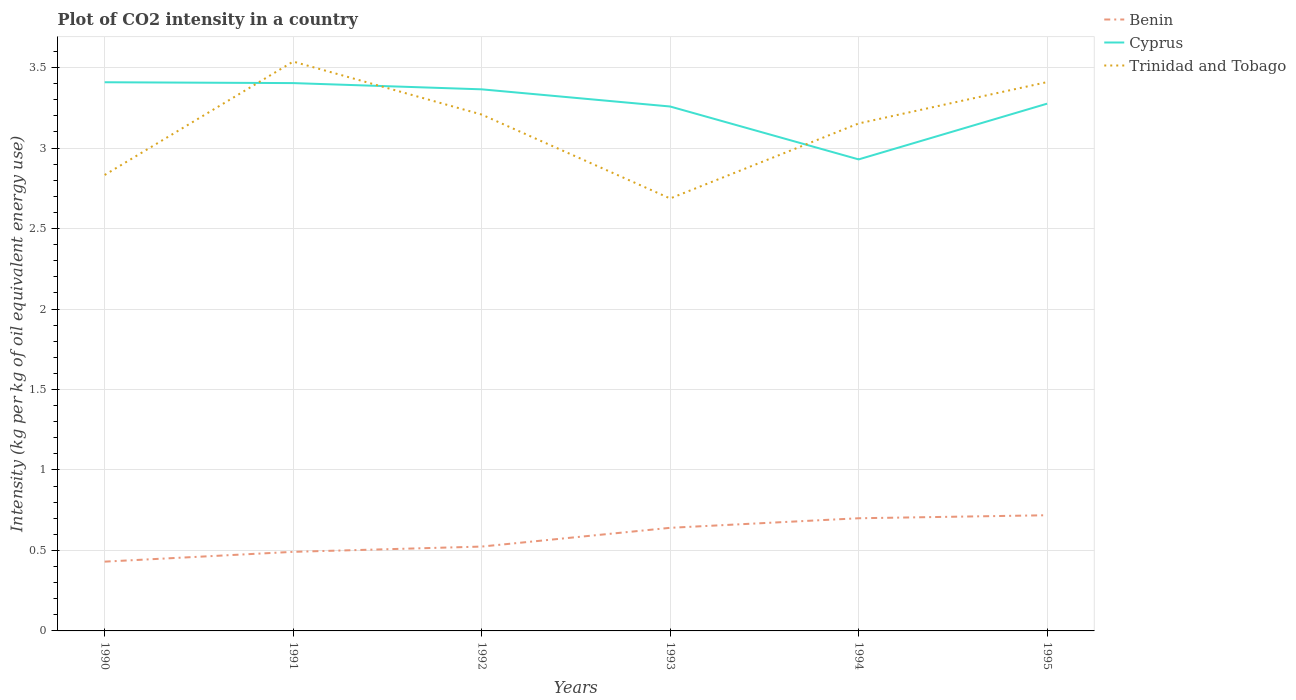How many different coloured lines are there?
Provide a succinct answer. 3. Does the line corresponding to Trinidad and Tobago intersect with the line corresponding to Cyprus?
Provide a succinct answer. Yes. Across all years, what is the maximum CO2 intensity in in Cyprus?
Your answer should be very brief. 2.93. What is the total CO2 intensity in in Benin in the graph?
Make the answer very short. -0.29. What is the difference between the highest and the second highest CO2 intensity in in Trinidad and Tobago?
Your response must be concise. 0.85. How many years are there in the graph?
Your answer should be compact. 6. Are the values on the major ticks of Y-axis written in scientific E-notation?
Offer a very short reply. No. Does the graph contain any zero values?
Your answer should be very brief. No. Where does the legend appear in the graph?
Your response must be concise. Top right. How many legend labels are there?
Make the answer very short. 3. What is the title of the graph?
Make the answer very short. Plot of CO2 intensity in a country. What is the label or title of the Y-axis?
Keep it short and to the point. Intensity (kg per kg of oil equivalent energy use). What is the Intensity (kg per kg of oil equivalent energy use) in Benin in 1990?
Provide a short and direct response. 0.43. What is the Intensity (kg per kg of oil equivalent energy use) in Cyprus in 1990?
Your response must be concise. 3.41. What is the Intensity (kg per kg of oil equivalent energy use) in Trinidad and Tobago in 1990?
Provide a short and direct response. 2.83. What is the Intensity (kg per kg of oil equivalent energy use) of Benin in 1991?
Make the answer very short. 0.49. What is the Intensity (kg per kg of oil equivalent energy use) in Cyprus in 1991?
Your answer should be very brief. 3.4. What is the Intensity (kg per kg of oil equivalent energy use) in Trinidad and Tobago in 1991?
Offer a very short reply. 3.54. What is the Intensity (kg per kg of oil equivalent energy use) of Benin in 1992?
Your answer should be very brief. 0.52. What is the Intensity (kg per kg of oil equivalent energy use) of Cyprus in 1992?
Make the answer very short. 3.36. What is the Intensity (kg per kg of oil equivalent energy use) in Trinidad and Tobago in 1992?
Keep it short and to the point. 3.21. What is the Intensity (kg per kg of oil equivalent energy use) in Benin in 1993?
Provide a short and direct response. 0.64. What is the Intensity (kg per kg of oil equivalent energy use) in Cyprus in 1993?
Your answer should be compact. 3.26. What is the Intensity (kg per kg of oil equivalent energy use) of Trinidad and Tobago in 1993?
Your answer should be very brief. 2.69. What is the Intensity (kg per kg of oil equivalent energy use) in Benin in 1994?
Provide a succinct answer. 0.7. What is the Intensity (kg per kg of oil equivalent energy use) of Cyprus in 1994?
Keep it short and to the point. 2.93. What is the Intensity (kg per kg of oil equivalent energy use) of Trinidad and Tobago in 1994?
Offer a very short reply. 3.15. What is the Intensity (kg per kg of oil equivalent energy use) of Benin in 1995?
Provide a succinct answer. 0.72. What is the Intensity (kg per kg of oil equivalent energy use) of Cyprus in 1995?
Make the answer very short. 3.28. What is the Intensity (kg per kg of oil equivalent energy use) in Trinidad and Tobago in 1995?
Offer a very short reply. 3.41. Across all years, what is the maximum Intensity (kg per kg of oil equivalent energy use) in Benin?
Provide a succinct answer. 0.72. Across all years, what is the maximum Intensity (kg per kg of oil equivalent energy use) in Cyprus?
Keep it short and to the point. 3.41. Across all years, what is the maximum Intensity (kg per kg of oil equivalent energy use) of Trinidad and Tobago?
Give a very brief answer. 3.54. Across all years, what is the minimum Intensity (kg per kg of oil equivalent energy use) in Benin?
Your answer should be compact. 0.43. Across all years, what is the minimum Intensity (kg per kg of oil equivalent energy use) in Cyprus?
Make the answer very short. 2.93. Across all years, what is the minimum Intensity (kg per kg of oil equivalent energy use) in Trinidad and Tobago?
Offer a very short reply. 2.69. What is the total Intensity (kg per kg of oil equivalent energy use) of Benin in the graph?
Your answer should be compact. 3.51. What is the total Intensity (kg per kg of oil equivalent energy use) in Cyprus in the graph?
Ensure brevity in your answer.  19.64. What is the total Intensity (kg per kg of oil equivalent energy use) of Trinidad and Tobago in the graph?
Give a very brief answer. 18.83. What is the difference between the Intensity (kg per kg of oil equivalent energy use) in Benin in 1990 and that in 1991?
Your response must be concise. -0.06. What is the difference between the Intensity (kg per kg of oil equivalent energy use) in Cyprus in 1990 and that in 1991?
Keep it short and to the point. 0.01. What is the difference between the Intensity (kg per kg of oil equivalent energy use) in Trinidad and Tobago in 1990 and that in 1991?
Make the answer very short. -0.7. What is the difference between the Intensity (kg per kg of oil equivalent energy use) of Benin in 1990 and that in 1992?
Your answer should be very brief. -0.09. What is the difference between the Intensity (kg per kg of oil equivalent energy use) in Cyprus in 1990 and that in 1992?
Provide a succinct answer. 0.04. What is the difference between the Intensity (kg per kg of oil equivalent energy use) in Trinidad and Tobago in 1990 and that in 1992?
Ensure brevity in your answer.  -0.38. What is the difference between the Intensity (kg per kg of oil equivalent energy use) in Benin in 1990 and that in 1993?
Your answer should be compact. -0.21. What is the difference between the Intensity (kg per kg of oil equivalent energy use) of Cyprus in 1990 and that in 1993?
Ensure brevity in your answer.  0.15. What is the difference between the Intensity (kg per kg of oil equivalent energy use) in Trinidad and Tobago in 1990 and that in 1993?
Keep it short and to the point. 0.15. What is the difference between the Intensity (kg per kg of oil equivalent energy use) in Benin in 1990 and that in 1994?
Keep it short and to the point. -0.27. What is the difference between the Intensity (kg per kg of oil equivalent energy use) of Cyprus in 1990 and that in 1994?
Keep it short and to the point. 0.48. What is the difference between the Intensity (kg per kg of oil equivalent energy use) of Trinidad and Tobago in 1990 and that in 1994?
Your answer should be compact. -0.32. What is the difference between the Intensity (kg per kg of oil equivalent energy use) of Benin in 1990 and that in 1995?
Give a very brief answer. -0.29. What is the difference between the Intensity (kg per kg of oil equivalent energy use) in Cyprus in 1990 and that in 1995?
Keep it short and to the point. 0.13. What is the difference between the Intensity (kg per kg of oil equivalent energy use) of Trinidad and Tobago in 1990 and that in 1995?
Provide a succinct answer. -0.58. What is the difference between the Intensity (kg per kg of oil equivalent energy use) of Benin in 1991 and that in 1992?
Your response must be concise. -0.03. What is the difference between the Intensity (kg per kg of oil equivalent energy use) of Cyprus in 1991 and that in 1992?
Offer a very short reply. 0.04. What is the difference between the Intensity (kg per kg of oil equivalent energy use) of Trinidad and Tobago in 1991 and that in 1992?
Offer a terse response. 0.33. What is the difference between the Intensity (kg per kg of oil equivalent energy use) in Benin in 1991 and that in 1993?
Your answer should be compact. -0.15. What is the difference between the Intensity (kg per kg of oil equivalent energy use) of Cyprus in 1991 and that in 1993?
Give a very brief answer. 0.15. What is the difference between the Intensity (kg per kg of oil equivalent energy use) of Trinidad and Tobago in 1991 and that in 1993?
Provide a succinct answer. 0.85. What is the difference between the Intensity (kg per kg of oil equivalent energy use) of Benin in 1991 and that in 1994?
Your answer should be very brief. -0.21. What is the difference between the Intensity (kg per kg of oil equivalent energy use) in Cyprus in 1991 and that in 1994?
Keep it short and to the point. 0.47. What is the difference between the Intensity (kg per kg of oil equivalent energy use) in Trinidad and Tobago in 1991 and that in 1994?
Provide a succinct answer. 0.38. What is the difference between the Intensity (kg per kg of oil equivalent energy use) in Benin in 1991 and that in 1995?
Provide a succinct answer. -0.23. What is the difference between the Intensity (kg per kg of oil equivalent energy use) of Cyprus in 1991 and that in 1995?
Offer a very short reply. 0.13. What is the difference between the Intensity (kg per kg of oil equivalent energy use) of Trinidad and Tobago in 1991 and that in 1995?
Ensure brevity in your answer.  0.13. What is the difference between the Intensity (kg per kg of oil equivalent energy use) of Benin in 1992 and that in 1993?
Offer a very short reply. -0.12. What is the difference between the Intensity (kg per kg of oil equivalent energy use) of Cyprus in 1992 and that in 1993?
Provide a short and direct response. 0.11. What is the difference between the Intensity (kg per kg of oil equivalent energy use) in Trinidad and Tobago in 1992 and that in 1993?
Make the answer very short. 0.52. What is the difference between the Intensity (kg per kg of oil equivalent energy use) in Benin in 1992 and that in 1994?
Make the answer very short. -0.18. What is the difference between the Intensity (kg per kg of oil equivalent energy use) of Cyprus in 1992 and that in 1994?
Give a very brief answer. 0.44. What is the difference between the Intensity (kg per kg of oil equivalent energy use) in Trinidad and Tobago in 1992 and that in 1994?
Provide a succinct answer. 0.06. What is the difference between the Intensity (kg per kg of oil equivalent energy use) in Benin in 1992 and that in 1995?
Your response must be concise. -0.19. What is the difference between the Intensity (kg per kg of oil equivalent energy use) in Cyprus in 1992 and that in 1995?
Make the answer very short. 0.09. What is the difference between the Intensity (kg per kg of oil equivalent energy use) of Trinidad and Tobago in 1992 and that in 1995?
Your answer should be very brief. -0.2. What is the difference between the Intensity (kg per kg of oil equivalent energy use) of Benin in 1993 and that in 1994?
Your answer should be very brief. -0.06. What is the difference between the Intensity (kg per kg of oil equivalent energy use) in Cyprus in 1993 and that in 1994?
Provide a succinct answer. 0.33. What is the difference between the Intensity (kg per kg of oil equivalent energy use) of Trinidad and Tobago in 1993 and that in 1994?
Give a very brief answer. -0.47. What is the difference between the Intensity (kg per kg of oil equivalent energy use) of Benin in 1993 and that in 1995?
Your answer should be very brief. -0.08. What is the difference between the Intensity (kg per kg of oil equivalent energy use) of Cyprus in 1993 and that in 1995?
Offer a very short reply. -0.02. What is the difference between the Intensity (kg per kg of oil equivalent energy use) of Trinidad and Tobago in 1993 and that in 1995?
Your answer should be very brief. -0.72. What is the difference between the Intensity (kg per kg of oil equivalent energy use) of Benin in 1994 and that in 1995?
Provide a succinct answer. -0.02. What is the difference between the Intensity (kg per kg of oil equivalent energy use) in Cyprus in 1994 and that in 1995?
Your answer should be very brief. -0.35. What is the difference between the Intensity (kg per kg of oil equivalent energy use) of Trinidad and Tobago in 1994 and that in 1995?
Provide a short and direct response. -0.26. What is the difference between the Intensity (kg per kg of oil equivalent energy use) of Benin in 1990 and the Intensity (kg per kg of oil equivalent energy use) of Cyprus in 1991?
Offer a very short reply. -2.97. What is the difference between the Intensity (kg per kg of oil equivalent energy use) in Benin in 1990 and the Intensity (kg per kg of oil equivalent energy use) in Trinidad and Tobago in 1991?
Your response must be concise. -3.11. What is the difference between the Intensity (kg per kg of oil equivalent energy use) of Cyprus in 1990 and the Intensity (kg per kg of oil equivalent energy use) of Trinidad and Tobago in 1991?
Provide a succinct answer. -0.13. What is the difference between the Intensity (kg per kg of oil equivalent energy use) in Benin in 1990 and the Intensity (kg per kg of oil equivalent energy use) in Cyprus in 1992?
Offer a terse response. -2.93. What is the difference between the Intensity (kg per kg of oil equivalent energy use) in Benin in 1990 and the Intensity (kg per kg of oil equivalent energy use) in Trinidad and Tobago in 1992?
Your answer should be compact. -2.78. What is the difference between the Intensity (kg per kg of oil equivalent energy use) of Cyprus in 1990 and the Intensity (kg per kg of oil equivalent energy use) of Trinidad and Tobago in 1992?
Your answer should be very brief. 0.2. What is the difference between the Intensity (kg per kg of oil equivalent energy use) of Benin in 1990 and the Intensity (kg per kg of oil equivalent energy use) of Cyprus in 1993?
Your answer should be very brief. -2.83. What is the difference between the Intensity (kg per kg of oil equivalent energy use) in Benin in 1990 and the Intensity (kg per kg of oil equivalent energy use) in Trinidad and Tobago in 1993?
Provide a short and direct response. -2.26. What is the difference between the Intensity (kg per kg of oil equivalent energy use) in Cyprus in 1990 and the Intensity (kg per kg of oil equivalent energy use) in Trinidad and Tobago in 1993?
Keep it short and to the point. 0.72. What is the difference between the Intensity (kg per kg of oil equivalent energy use) of Benin in 1990 and the Intensity (kg per kg of oil equivalent energy use) of Cyprus in 1994?
Offer a terse response. -2.5. What is the difference between the Intensity (kg per kg of oil equivalent energy use) of Benin in 1990 and the Intensity (kg per kg of oil equivalent energy use) of Trinidad and Tobago in 1994?
Make the answer very short. -2.72. What is the difference between the Intensity (kg per kg of oil equivalent energy use) in Cyprus in 1990 and the Intensity (kg per kg of oil equivalent energy use) in Trinidad and Tobago in 1994?
Ensure brevity in your answer.  0.26. What is the difference between the Intensity (kg per kg of oil equivalent energy use) of Benin in 1990 and the Intensity (kg per kg of oil equivalent energy use) of Cyprus in 1995?
Provide a succinct answer. -2.85. What is the difference between the Intensity (kg per kg of oil equivalent energy use) of Benin in 1990 and the Intensity (kg per kg of oil equivalent energy use) of Trinidad and Tobago in 1995?
Your response must be concise. -2.98. What is the difference between the Intensity (kg per kg of oil equivalent energy use) in Cyprus in 1990 and the Intensity (kg per kg of oil equivalent energy use) in Trinidad and Tobago in 1995?
Provide a succinct answer. -0. What is the difference between the Intensity (kg per kg of oil equivalent energy use) in Benin in 1991 and the Intensity (kg per kg of oil equivalent energy use) in Cyprus in 1992?
Offer a terse response. -2.87. What is the difference between the Intensity (kg per kg of oil equivalent energy use) of Benin in 1991 and the Intensity (kg per kg of oil equivalent energy use) of Trinidad and Tobago in 1992?
Your answer should be very brief. -2.72. What is the difference between the Intensity (kg per kg of oil equivalent energy use) of Cyprus in 1991 and the Intensity (kg per kg of oil equivalent energy use) of Trinidad and Tobago in 1992?
Make the answer very short. 0.2. What is the difference between the Intensity (kg per kg of oil equivalent energy use) in Benin in 1991 and the Intensity (kg per kg of oil equivalent energy use) in Cyprus in 1993?
Your answer should be very brief. -2.77. What is the difference between the Intensity (kg per kg of oil equivalent energy use) of Benin in 1991 and the Intensity (kg per kg of oil equivalent energy use) of Trinidad and Tobago in 1993?
Offer a very short reply. -2.2. What is the difference between the Intensity (kg per kg of oil equivalent energy use) of Cyprus in 1991 and the Intensity (kg per kg of oil equivalent energy use) of Trinidad and Tobago in 1993?
Your answer should be compact. 0.72. What is the difference between the Intensity (kg per kg of oil equivalent energy use) of Benin in 1991 and the Intensity (kg per kg of oil equivalent energy use) of Cyprus in 1994?
Offer a terse response. -2.44. What is the difference between the Intensity (kg per kg of oil equivalent energy use) of Benin in 1991 and the Intensity (kg per kg of oil equivalent energy use) of Trinidad and Tobago in 1994?
Ensure brevity in your answer.  -2.66. What is the difference between the Intensity (kg per kg of oil equivalent energy use) of Cyprus in 1991 and the Intensity (kg per kg of oil equivalent energy use) of Trinidad and Tobago in 1994?
Offer a terse response. 0.25. What is the difference between the Intensity (kg per kg of oil equivalent energy use) of Benin in 1991 and the Intensity (kg per kg of oil equivalent energy use) of Cyprus in 1995?
Provide a succinct answer. -2.78. What is the difference between the Intensity (kg per kg of oil equivalent energy use) of Benin in 1991 and the Intensity (kg per kg of oil equivalent energy use) of Trinidad and Tobago in 1995?
Provide a succinct answer. -2.92. What is the difference between the Intensity (kg per kg of oil equivalent energy use) of Cyprus in 1991 and the Intensity (kg per kg of oil equivalent energy use) of Trinidad and Tobago in 1995?
Your answer should be compact. -0.01. What is the difference between the Intensity (kg per kg of oil equivalent energy use) of Benin in 1992 and the Intensity (kg per kg of oil equivalent energy use) of Cyprus in 1993?
Give a very brief answer. -2.73. What is the difference between the Intensity (kg per kg of oil equivalent energy use) in Benin in 1992 and the Intensity (kg per kg of oil equivalent energy use) in Trinidad and Tobago in 1993?
Keep it short and to the point. -2.16. What is the difference between the Intensity (kg per kg of oil equivalent energy use) of Cyprus in 1992 and the Intensity (kg per kg of oil equivalent energy use) of Trinidad and Tobago in 1993?
Offer a very short reply. 0.68. What is the difference between the Intensity (kg per kg of oil equivalent energy use) of Benin in 1992 and the Intensity (kg per kg of oil equivalent energy use) of Cyprus in 1994?
Provide a short and direct response. -2.41. What is the difference between the Intensity (kg per kg of oil equivalent energy use) in Benin in 1992 and the Intensity (kg per kg of oil equivalent energy use) in Trinidad and Tobago in 1994?
Your answer should be compact. -2.63. What is the difference between the Intensity (kg per kg of oil equivalent energy use) in Cyprus in 1992 and the Intensity (kg per kg of oil equivalent energy use) in Trinidad and Tobago in 1994?
Make the answer very short. 0.21. What is the difference between the Intensity (kg per kg of oil equivalent energy use) in Benin in 1992 and the Intensity (kg per kg of oil equivalent energy use) in Cyprus in 1995?
Ensure brevity in your answer.  -2.75. What is the difference between the Intensity (kg per kg of oil equivalent energy use) in Benin in 1992 and the Intensity (kg per kg of oil equivalent energy use) in Trinidad and Tobago in 1995?
Provide a succinct answer. -2.89. What is the difference between the Intensity (kg per kg of oil equivalent energy use) in Cyprus in 1992 and the Intensity (kg per kg of oil equivalent energy use) in Trinidad and Tobago in 1995?
Provide a short and direct response. -0.04. What is the difference between the Intensity (kg per kg of oil equivalent energy use) of Benin in 1993 and the Intensity (kg per kg of oil equivalent energy use) of Cyprus in 1994?
Your answer should be very brief. -2.29. What is the difference between the Intensity (kg per kg of oil equivalent energy use) of Benin in 1993 and the Intensity (kg per kg of oil equivalent energy use) of Trinidad and Tobago in 1994?
Provide a succinct answer. -2.51. What is the difference between the Intensity (kg per kg of oil equivalent energy use) of Cyprus in 1993 and the Intensity (kg per kg of oil equivalent energy use) of Trinidad and Tobago in 1994?
Ensure brevity in your answer.  0.11. What is the difference between the Intensity (kg per kg of oil equivalent energy use) in Benin in 1993 and the Intensity (kg per kg of oil equivalent energy use) in Cyprus in 1995?
Provide a short and direct response. -2.64. What is the difference between the Intensity (kg per kg of oil equivalent energy use) of Benin in 1993 and the Intensity (kg per kg of oil equivalent energy use) of Trinidad and Tobago in 1995?
Your response must be concise. -2.77. What is the difference between the Intensity (kg per kg of oil equivalent energy use) in Cyprus in 1993 and the Intensity (kg per kg of oil equivalent energy use) in Trinidad and Tobago in 1995?
Make the answer very short. -0.15. What is the difference between the Intensity (kg per kg of oil equivalent energy use) in Benin in 1994 and the Intensity (kg per kg of oil equivalent energy use) in Cyprus in 1995?
Offer a very short reply. -2.58. What is the difference between the Intensity (kg per kg of oil equivalent energy use) of Benin in 1994 and the Intensity (kg per kg of oil equivalent energy use) of Trinidad and Tobago in 1995?
Offer a very short reply. -2.71. What is the difference between the Intensity (kg per kg of oil equivalent energy use) of Cyprus in 1994 and the Intensity (kg per kg of oil equivalent energy use) of Trinidad and Tobago in 1995?
Provide a short and direct response. -0.48. What is the average Intensity (kg per kg of oil equivalent energy use) in Benin per year?
Offer a very short reply. 0.58. What is the average Intensity (kg per kg of oil equivalent energy use) of Cyprus per year?
Offer a terse response. 3.27. What is the average Intensity (kg per kg of oil equivalent energy use) of Trinidad and Tobago per year?
Your answer should be very brief. 3.14. In the year 1990, what is the difference between the Intensity (kg per kg of oil equivalent energy use) of Benin and Intensity (kg per kg of oil equivalent energy use) of Cyprus?
Provide a short and direct response. -2.98. In the year 1990, what is the difference between the Intensity (kg per kg of oil equivalent energy use) of Benin and Intensity (kg per kg of oil equivalent energy use) of Trinidad and Tobago?
Your response must be concise. -2.4. In the year 1990, what is the difference between the Intensity (kg per kg of oil equivalent energy use) in Cyprus and Intensity (kg per kg of oil equivalent energy use) in Trinidad and Tobago?
Your answer should be very brief. 0.58. In the year 1991, what is the difference between the Intensity (kg per kg of oil equivalent energy use) in Benin and Intensity (kg per kg of oil equivalent energy use) in Cyprus?
Ensure brevity in your answer.  -2.91. In the year 1991, what is the difference between the Intensity (kg per kg of oil equivalent energy use) in Benin and Intensity (kg per kg of oil equivalent energy use) in Trinidad and Tobago?
Offer a terse response. -3.05. In the year 1991, what is the difference between the Intensity (kg per kg of oil equivalent energy use) of Cyprus and Intensity (kg per kg of oil equivalent energy use) of Trinidad and Tobago?
Your answer should be very brief. -0.13. In the year 1992, what is the difference between the Intensity (kg per kg of oil equivalent energy use) of Benin and Intensity (kg per kg of oil equivalent energy use) of Cyprus?
Provide a succinct answer. -2.84. In the year 1992, what is the difference between the Intensity (kg per kg of oil equivalent energy use) of Benin and Intensity (kg per kg of oil equivalent energy use) of Trinidad and Tobago?
Make the answer very short. -2.68. In the year 1992, what is the difference between the Intensity (kg per kg of oil equivalent energy use) of Cyprus and Intensity (kg per kg of oil equivalent energy use) of Trinidad and Tobago?
Provide a short and direct response. 0.16. In the year 1993, what is the difference between the Intensity (kg per kg of oil equivalent energy use) of Benin and Intensity (kg per kg of oil equivalent energy use) of Cyprus?
Your answer should be compact. -2.62. In the year 1993, what is the difference between the Intensity (kg per kg of oil equivalent energy use) of Benin and Intensity (kg per kg of oil equivalent energy use) of Trinidad and Tobago?
Ensure brevity in your answer.  -2.05. In the year 1993, what is the difference between the Intensity (kg per kg of oil equivalent energy use) in Cyprus and Intensity (kg per kg of oil equivalent energy use) in Trinidad and Tobago?
Ensure brevity in your answer.  0.57. In the year 1994, what is the difference between the Intensity (kg per kg of oil equivalent energy use) of Benin and Intensity (kg per kg of oil equivalent energy use) of Cyprus?
Provide a short and direct response. -2.23. In the year 1994, what is the difference between the Intensity (kg per kg of oil equivalent energy use) of Benin and Intensity (kg per kg of oil equivalent energy use) of Trinidad and Tobago?
Offer a very short reply. -2.45. In the year 1994, what is the difference between the Intensity (kg per kg of oil equivalent energy use) of Cyprus and Intensity (kg per kg of oil equivalent energy use) of Trinidad and Tobago?
Offer a terse response. -0.22. In the year 1995, what is the difference between the Intensity (kg per kg of oil equivalent energy use) of Benin and Intensity (kg per kg of oil equivalent energy use) of Cyprus?
Ensure brevity in your answer.  -2.56. In the year 1995, what is the difference between the Intensity (kg per kg of oil equivalent energy use) of Benin and Intensity (kg per kg of oil equivalent energy use) of Trinidad and Tobago?
Your answer should be compact. -2.69. In the year 1995, what is the difference between the Intensity (kg per kg of oil equivalent energy use) in Cyprus and Intensity (kg per kg of oil equivalent energy use) in Trinidad and Tobago?
Offer a very short reply. -0.13. What is the ratio of the Intensity (kg per kg of oil equivalent energy use) of Benin in 1990 to that in 1991?
Your response must be concise. 0.88. What is the ratio of the Intensity (kg per kg of oil equivalent energy use) of Cyprus in 1990 to that in 1991?
Your response must be concise. 1. What is the ratio of the Intensity (kg per kg of oil equivalent energy use) in Trinidad and Tobago in 1990 to that in 1991?
Provide a short and direct response. 0.8. What is the ratio of the Intensity (kg per kg of oil equivalent energy use) of Benin in 1990 to that in 1992?
Provide a succinct answer. 0.82. What is the ratio of the Intensity (kg per kg of oil equivalent energy use) of Cyprus in 1990 to that in 1992?
Ensure brevity in your answer.  1.01. What is the ratio of the Intensity (kg per kg of oil equivalent energy use) of Trinidad and Tobago in 1990 to that in 1992?
Offer a terse response. 0.88. What is the ratio of the Intensity (kg per kg of oil equivalent energy use) of Benin in 1990 to that in 1993?
Give a very brief answer. 0.67. What is the ratio of the Intensity (kg per kg of oil equivalent energy use) in Cyprus in 1990 to that in 1993?
Your answer should be very brief. 1.05. What is the ratio of the Intensity (kg per kg of oil equivalent energy use) in Trinidad and Tobago in 1990 to that in 1993?
Provide a succinct answer. 1.05. What is the ratio of the Intensity (kg per kg of oil equivalent energy use) in Benin in 1990 to that in 1994?
Provide a succinct answer. 0.61. What is the ratio of the Intensity (kg per kg of oil equivalent energy use) in Cyprus in 1990 to that in 1994?
Provide a succinct answer. 1.16. What is the ratio of the Intensity (kg per kg of oil equivalent energy use) of Trinidad and Tobago in 1990 to that in 1994?
Offer a very short reply. 0.9. What is the ratio of the Intensity (kg per kg of oil equivalent energy use) in Benin in 1990 to that in 1995?
Make the answer very short. 0.6. What is the ratio of the Intensity (kg per kg of oil equivalent energy use) of Cyprus in 1990 to that in 1995?
Give a very brief answer. 1.04. What is the ratio of the Intensity (kg per kg of oil equivalent energy use) in Trinidad and Tobago in 1990 to that in 1995?
Provide a short and direct response. 0.83. What is the ratio of the Intensity (kg per kg of oil equivalent energy use) in Benin in 1991 to that in 1992?
Offer a very short reply. 0.94. What is the ratio of the Intensity (kg per kg of oil equivalent energy use) of Cyprus in 1991 to that in 1992?
Your answer should be compact. 1.01. What is the ratio of the Intensity (kg per kg of oil equivalent energy use) in Trinidad and Tobago in 1991 to that in 1992?
Your response must be concise. 1.1. What is the ratio of the Intensity (kg per kg of oil equivalent energy use) of Benin in 1991 to that in 1993?
Your response must be concise. 0.77. What is the ratio of the Intensity (kg per kg of oil equivalent energy use) in Cyprus in 1991 to that in 1993?
Your response must be concise. 1.04. What is the ratio of the Intensity (kg per kg of oil equivalent energy use) in Trinidad and Tobago in 1991 to that in 1993?
Provide a short and direct response. 1.32. What is the ratio of the Intensity (kg per kg of oil equivalent energy use) in Benin in 1991 to that in 1994?
Offer a terse response. 0.7. What is the ratio of the Intensity (kg per kg of oil equivalent energy use) in Cyprus in 1991 to that in 1994?
Provide a short and direct response. 1.16. What is the ratio of the Intensity (kg per kg of oil equivalent energy use) in Trinidad and Tobago in 1991 to that in 1994?
Ensure brevity in your answer.  1.12. What is the ratio of the Intensity (kg per kg of oil equivalent energy use) of Benin in 1991 to that in 1995?
Give a very brief answer. 0.68. What is the ratio of the Intensity (kg per kg of oil equivalent energy use) of Cyprus in 1991 to that in 1995?
Your response must be concise. 1.04. What is the ratio of the Intensity (kg per kg of oil equivalent energy use) of Trinidad and Tobago in 1991 to that in 1995?
Your answer should be compact. 1.04. What is the ratio of the Intensity (kg per kg of oil equivalent energy use) of Benin in 1992 to that in 1993?
Give a very brief answer. 0.82. What is the ratio of the Intensity (kg per kg of oil equivalent energy use) of Cyprus in 1992 to that in 1993?
Give a very brief answer. 1.03. What is the ratio of the Intensity (kg per kg of oil equivalent energy use) in Trinidad and Tobago in 1992 to that in 1993?
Give a very brief answer. 1.19. What is the ratio of the Intensity (kg per kg of oil equivalent energy use) in Benin in 1992 to that in 1994?
Your answer should be compact. 0.75. What is the ratio of the Intensity (kg per kg of oil equivalent energy use) of Cyprus in 1992 to that in 1994?
Keep it short and to the point. 1.15. What is the ratio of the Intensity (kg per kg of oil equivalent energy use) of Trinidad and Tobago in 1992 to that in 1994?
Provide a succinct answer. 1.02. What is the ratio of the Intensity (kg per kg of oil equivalent energy use) of Benin in 1992 to that in 1995?
Give a very brief answer. 0.73. What is the ratio of the Intensity (kg per kg of oil equivalent energy use) of Cyprus in 1992 to that in 1995?
Give a very brief answer. 1.03. What is the ratio of the Intensity (kg per kg of oil equivalent energy use) in Trinidad and Tobago in 1992 to that in 1995?
Your answer should be compact. 0.94. What is the ratio of the Intensity (kg per kg of oil equivalent energy use) of Benin in 1993 to that in 1994?
Provide a succinct answer. 0.92. What is the ratio of the Intensity (kg per kg of oil equivalent energy use) in Cyprus in 1993 to that in 1994?
Make the answer very short. 1.11. What is the ratio of the Intensity (kg per kg of oil equivalent energy use) of Trinidad and Tobago in 1993 to that in 1994?
Your answer should be very brief. 0.85. What is the ratio of the Intensity (kg per kg of oil equivalent energy use) of Benin in 1993 to that in 1995?
Your answer should be compact. 0.89. What is the ratio of the Intensity (kg per kg of oil equivalent energy use) of Trinidad and Tobago in 1993 to that in 1995?
Keep it short and to the point. 0.79. What is the ratio of the Intensity (kg per kg of oil equivalent energy use) of Benin in 1994 to that in 1995?
Offer a very short reply. 0.97. What is the ratio of the Intensity (kg per kg of oil equivalent energy use) of Cyprus in 1994 to that in 1995?
Offer a terse response. 0.89. What is the ratio of the Intensity (kg per kg of oil equivalent energy use) of Trinidad and Tobago in 1994 to that in 1995?
Provide a short and direct response. 0.92. What is the difference between the highest and the second highest Intensity (kg per kg of oil equivalent energy use) in Benin?
Ensure brevity in your answer.  0.02. What is the difference between the highest and the second highest Intensity (kg per kg of oil equivalent energy use) in Cyprus?
Your answer should be very brief. 0.01. What is the difference between the highest and the second highest Intensity (kg per kg of oil equivalent energy use) in Trinidad and Tobago?
Give a very brief answer. 0.13. What is the difference between the highest and the lowest Intensity (kg per kg of oil equivalent energy use) in Benin?
Offer a terse response. 0.29. What is the difference between the highest and the lowest Intensity (kg per kg of oil equivalent energy use) of Cyprus?
Your response must be concise. 0.48. What is the difference between the highest and the lowest Intensity (kg per kg of oil equivalent energy use) of Trinidad and Tobago?
Offer a terse response. 0.85. 